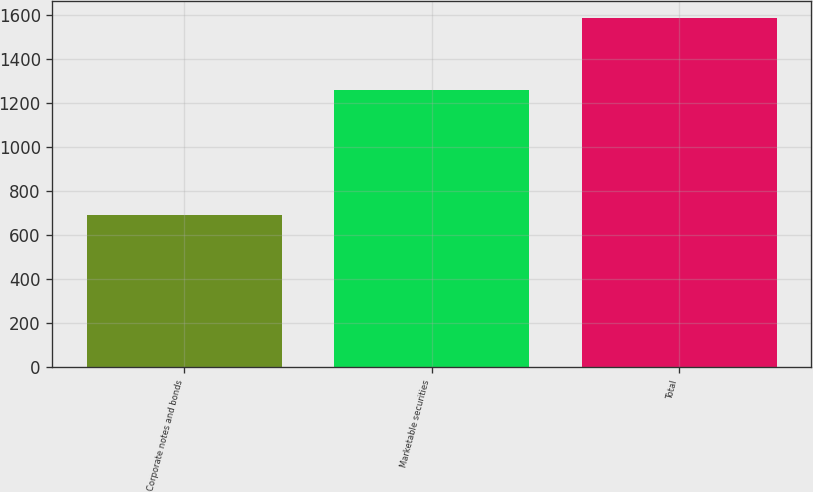<chart> <loc_0><loc_0><loc_500><loc_500><bar_chart><fcel>Corporate notes and bonds<fcel>Marketable securities<fcel>Total<nl><fcel>693<fcel>1257<fcel>1585<nl></chart> 